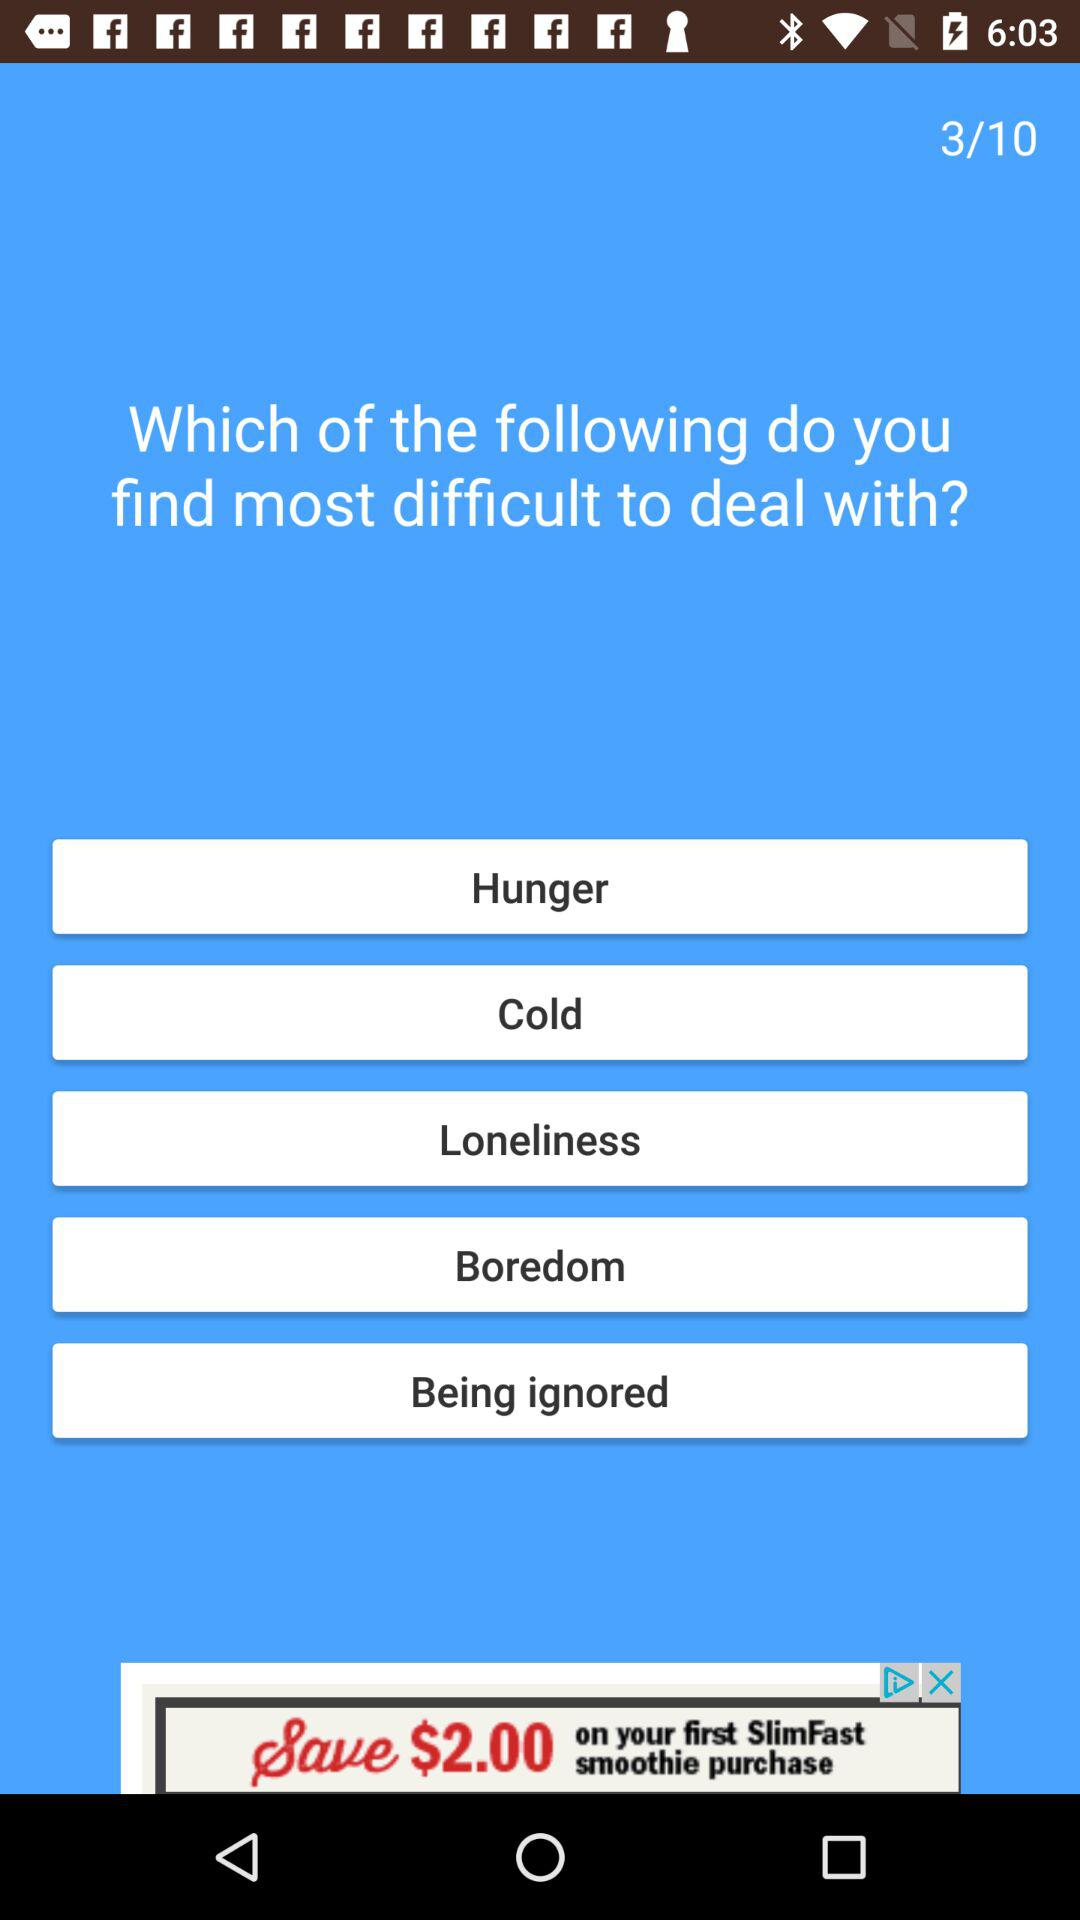What is the total number of given questions? The total number of given questions is 10. 